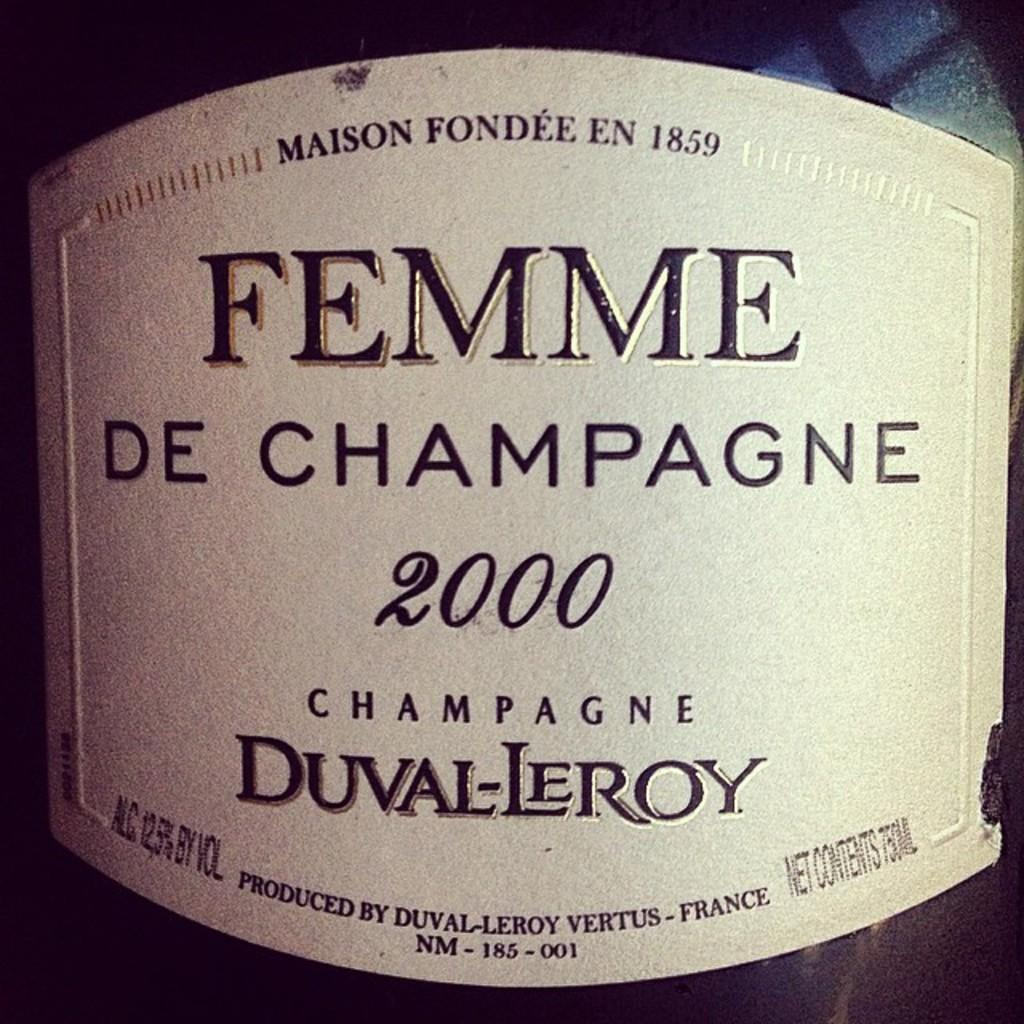What is featured on the poster in the image? There is a poster in the image, and it contains numbers and text. Can you describe the content of the poster in more detail? The poster contains numbers and text, but the specific information or context cannot be determined from the image alone. What type of light can be seen emanating from the poster in the image? There is no light emanating from the poster in the image; it is a static, printed poster. 